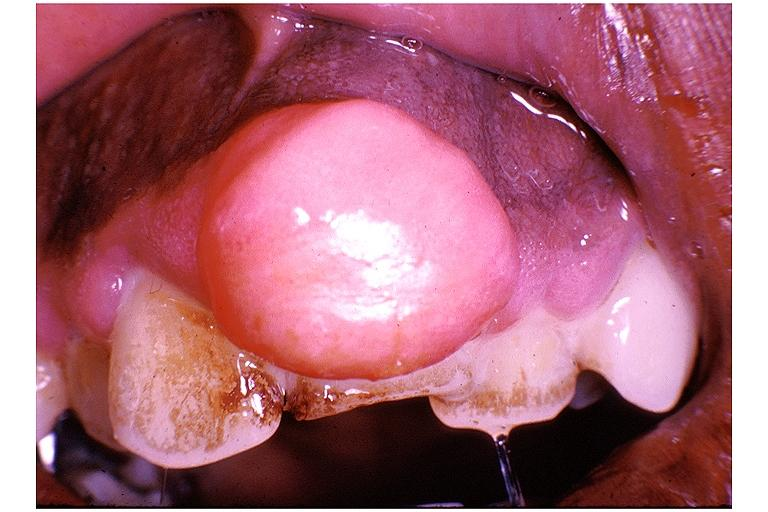does hilar cell tumor show periodontal fibroma?
Answer the question using a single word or phrase. No 